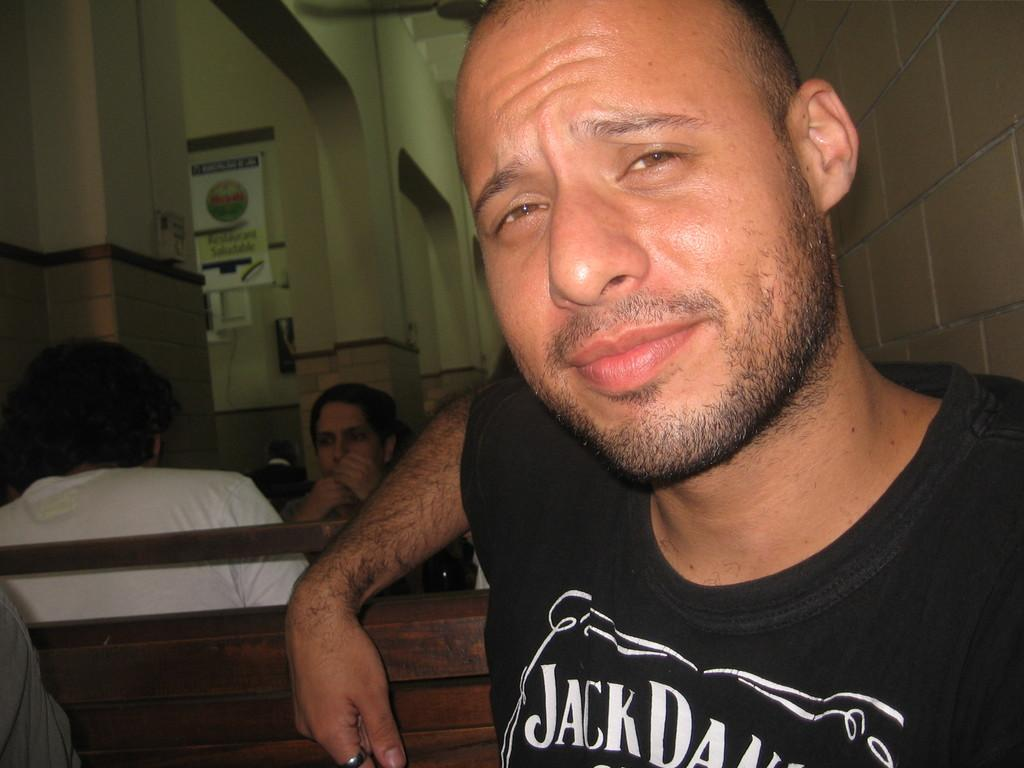What is the man in the image doing? There is a man sitting in the image. How many people are sitting in the image? There are people sitting in the image. What can be seen in the background of the image? There is a board and a fan in the background of the image. What type of structure is visible in the image? There are walls visible in the image. Can you tell me how many goldfish are swimming in the frame in the image? There are no goldfish or frames present in the image. What type of soda is being served to the people in the image? There is no soda visible in the image; only people sitting and a background with a board and fan are present. 